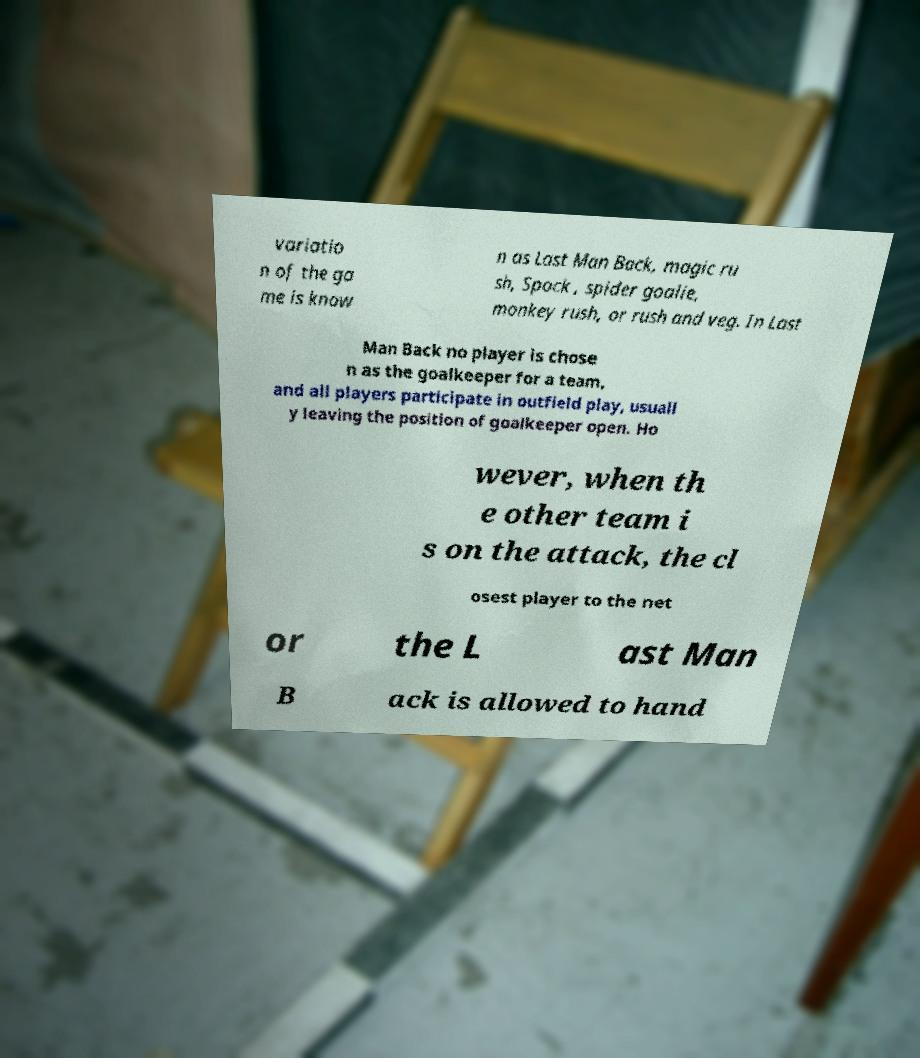Can you accurately transcribe the text from the provided image for me? variatio n of the ga me is know n as Last Man Back, magic ru sh, Spock , spider goalie, monkey rush, or rush and veg. In Last Man Back no player is chose n as the goalkeeper for a team, and all players participate in outfield play, usuall y leaving the position of goalkeeper open. Ho wever, when th e other team i s on the attack, the cl osest player to the net or the L ast Man B ack is allowed to hand 